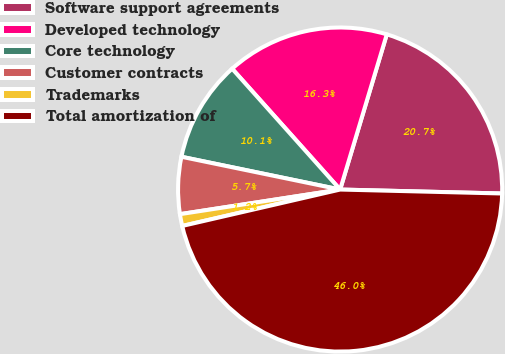<chart> <loc_0><loc_0><loc_500><loc_500><pie_chart><fcel>Software support agreements<fcel>Developed technology<fcel>Core technology<fcel>Customer contracts<fcel>Trademarks<fcel>Total amortization of<nl><fcel>20.74%<fcel>16.26%<fcel>10.15%<fcel>5.67%<fcel>1.18%<fcel>46.01%<nl></chart> 